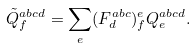Convert formula to latex. <formula><loc_0><loc_0><loc_500><loc_500>\tilde { Q } ^ { a b c d } _ { f } = \sum _ { e } ( F ^ { a b c } _ { d } ) ^ { e } _ { f } Q ^ { a b c d } _ { e } .</formula> 